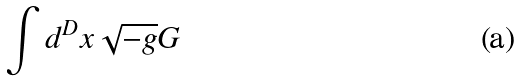Convert formula to latex. <formula><loc_0><loc_0><loc_500><loc_500>\int d ^ { D } x \sqrt { - g } G</formula> 